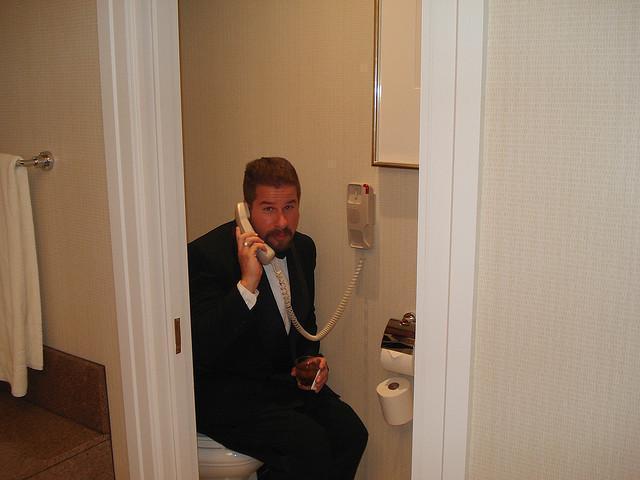What is he doing?
From the following four choices, select the correct answer to address the question.
Options: Cleaning up, speaking phone, hiding himself, hiding drink. Speaking phone. 